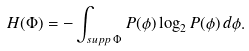<formula> <loc_0><loc_0><loc_500><loc_500>H ( { \Phi } ) = - \int _ { s u p p \, \Phi } P ( \phi ) \log _ { 2 } P ( \phi ) \, d \phi .</formula> 